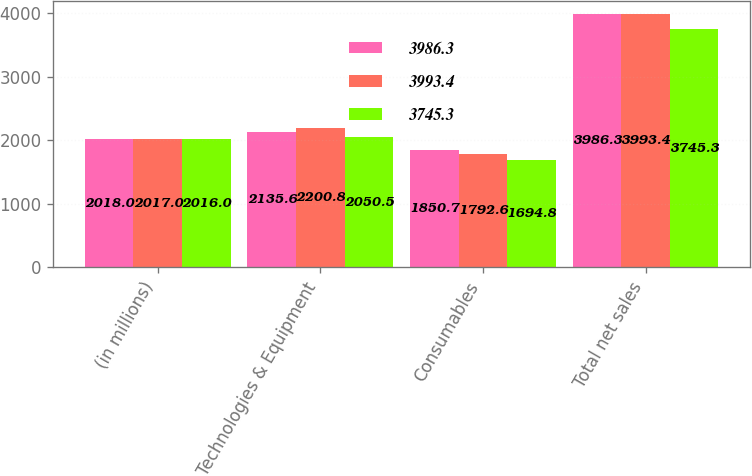<chart> <loc_0><loc_0><loc_500><loc_500><stacked_bar_chart><ecel><fcel>(in millions)<fcel>Technologies & Equipment<fcel>Consumables<fcel>Total net sales<nl><fcel>3986.3<fcel>2018<fcel>2135.6<fcel>1850.7<fcel>3986.3<nl><fcel>3993.4<fcel>2017<fcel>2200.8<fcel>1792.6<fcel>3993.4<nl><fcel>3745.3<fcel>2016<fcel>2050.5<fcel>1694.8<fcel>3745.3<nl></chart> 